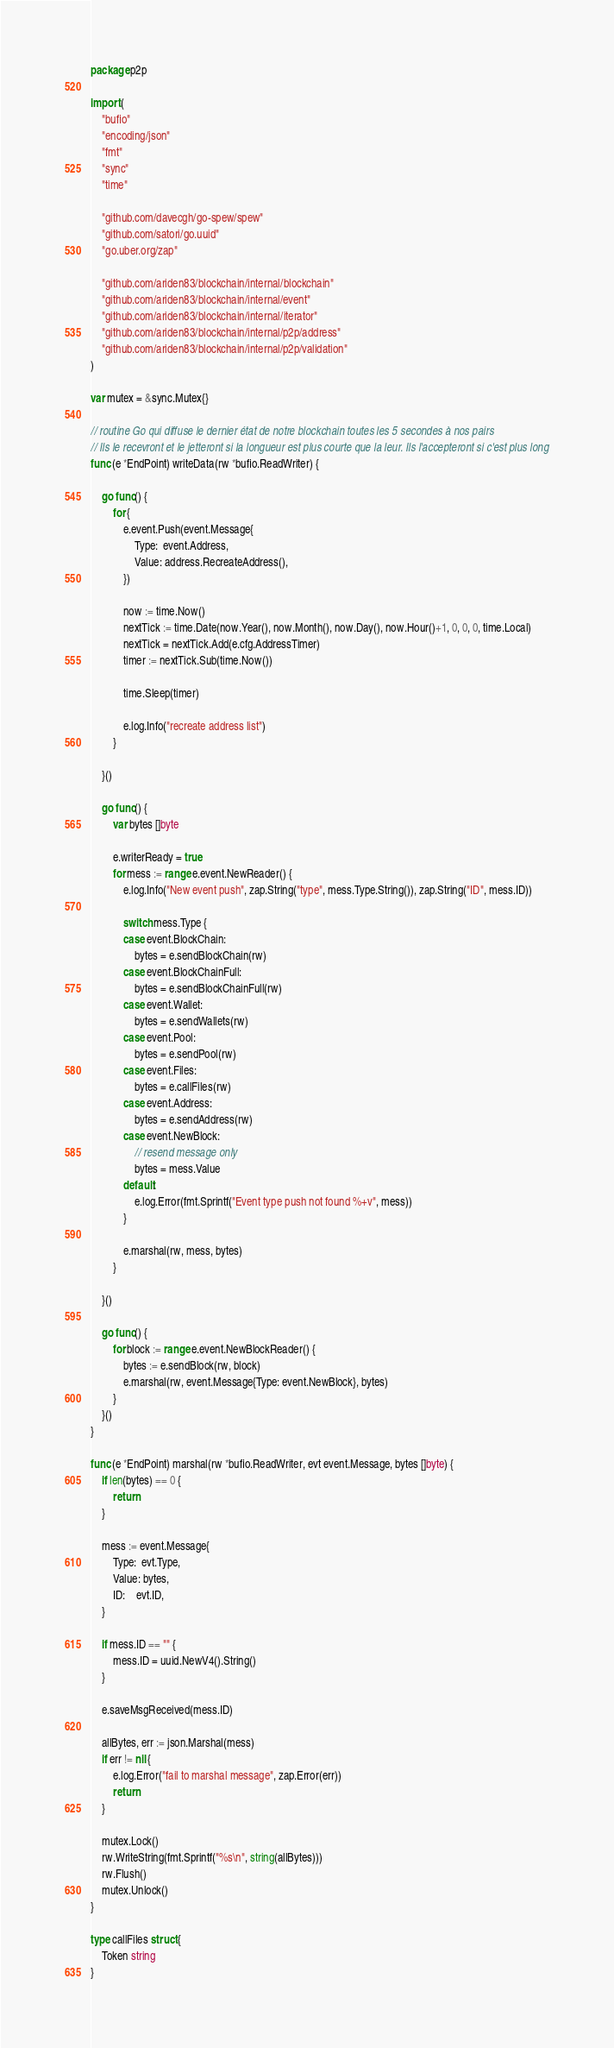<code> <loc_0><loc_0><loc_500><loc_500><_Go_>package p2p

import (
	"bufio"
	"encoding/json"
	"fmt"
	"sync"
	"time"

	"github.com/davecgh/go-spew/spew"
	"github.com/satori/go.uuid"
	"go.uber.org/zap"

	"github.com/ariden83/blockchain/internal/blockchain"
	"github.com/ariden83/blockchain/internal/event"
	"github.com/ariden83/blockchain/internal/iterator"
	"github.com/ariden83/blockchain/internal/p2p/address"
	"github.com/ariden83/blockchain/internal/p2p/validation"
)

var mutex = &sync.Mutex{}

// routine Go qui diffuse le dernier état de notre blockchain toutes les 5 secondes à nos pairs
// Ils le recevront et le jetteront si la longueur est plus courte que la leur. Ils l'accepteront si c'est plus long
func (e *EndPoint) writeData(rw *bufio.ReadWriter) {

	go func() {
		for {
			e.event.Push(event.Message{
				Type:  event.Address,
				Value: address.RecreateAddress(),
			})

			now := time.Now()
			nextTick := time.Date(now.Year(), now.Month(), now.Day(), now.Hour()+1, 0, 0, 0, time.Local)
			nextTick = nextTick.Add(e.cfg.AddressTimer)
			timer := nextTick.Sub(time.Now())

			time.Sleep(timer)

			e.log.Info("recreate address list")
		}

	}()

	go func() {
		var bytes []byte

		e.writerReady = true
		for mess := range e.event.NewReader() {
			e.log.Info("New event push", zap.String("type", mess.Type.String()), zap.String("ID", mess.ID))

			switch mess.Type {
			case event.BlockChain:
				bytes = e.sendBlockChain(rw)
			case event.BlockChainFull:
				bytes = e.sendBlockChainFull(rw)
			case event.Wallet:
				bytes = e.sendWallets(rw)
			case event.Pool:
				bytes = e.sendPool(rw)
			case event.Files:
				bytes = e.callFiles(rw)
			case event.Address:
				bytes = e.sendAddress(rw)
			case event.NewBlock:
				// resend message only
				bytes = mess.Value
			default:
				e.log.Error(fmt.Sprintf("Event type push not found %+v", mess))
			}

			e.marshal(rw, mess, bytes)
		}

	}()

	go func() {
		for block := range e.event.NewBlockReader() {
			bytes := e.sendBlock(rw, block)
			e.marshal(rw, event.Message{Type: event.NewBlock}, bytes)
		}
	}()
}

func (e *EndPoint) marshal(rw *bufio.ReadWriter, evt event.Message, bytes []byte) {
	if len(bytes) == 0 {
		return
	}

	mess := event.Message{
		Type:  evt.Type,
		Value: bytes,
		ID:    evt.ID,
	}

	if mess.ID == "" {
		mess.ID = uuid.NewV4().String()
	}

	e.saveMsgReceived(mess.ID)

	allBytes, err := json.Marshal(mess)
	if err != nil {
		e.log.Error("fail to marshal message", zap.Error(err))
		return
	}

	mutex.Lock()
	rw.WriteString(fmt.Sprintf("%s\n", string(allBytes)))
	rw.Flush()
	mutex.Unlock()
}

type callFiles struct {
	Token string
}
</code> 